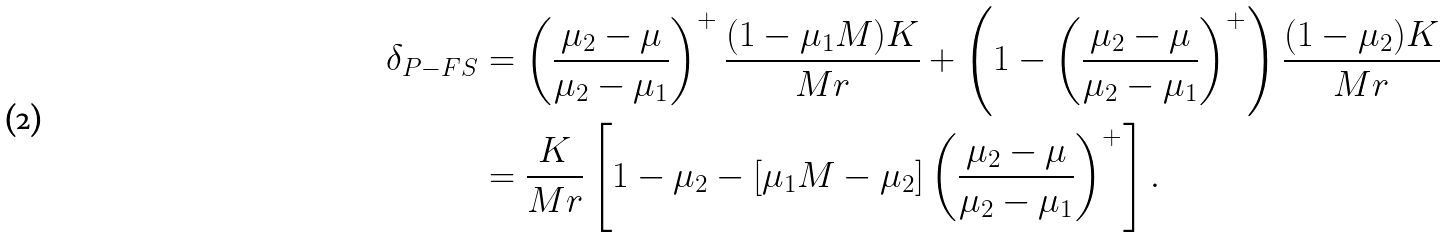<formula> <loc_0><loc_0><loc_500><loc_500>\delta _ { P - F S } & = \left ( \frac { \mu _ { 2 } - \mu } { \mu _ { 2 } - \mu _ { 1 } } \right ) ^ { + } \frac { ( 1 - \mu _ { 1 } M ) K } { M r } + \left ( 1 - \left ( \frac { \mu _ { 2 } - \mu } { \mu _ { 2 } - \mu _ { 1 } } \right ) ^ { + } \right ) \frac { ( 1 - \mu _ { 2 } ) K } { M r } \\ & = \frac { K } { M r } \left [ 1 - \mu _ { 2 } - \left [ \mu _ { 1 } M - \mu _ { 2 } \right ] \left ( \frac { \mu _ { 2 } - \mu } { \mu _ { 2 } - \mu _ { 1 } } \right ) ^ { + } \right ] .</formula> 